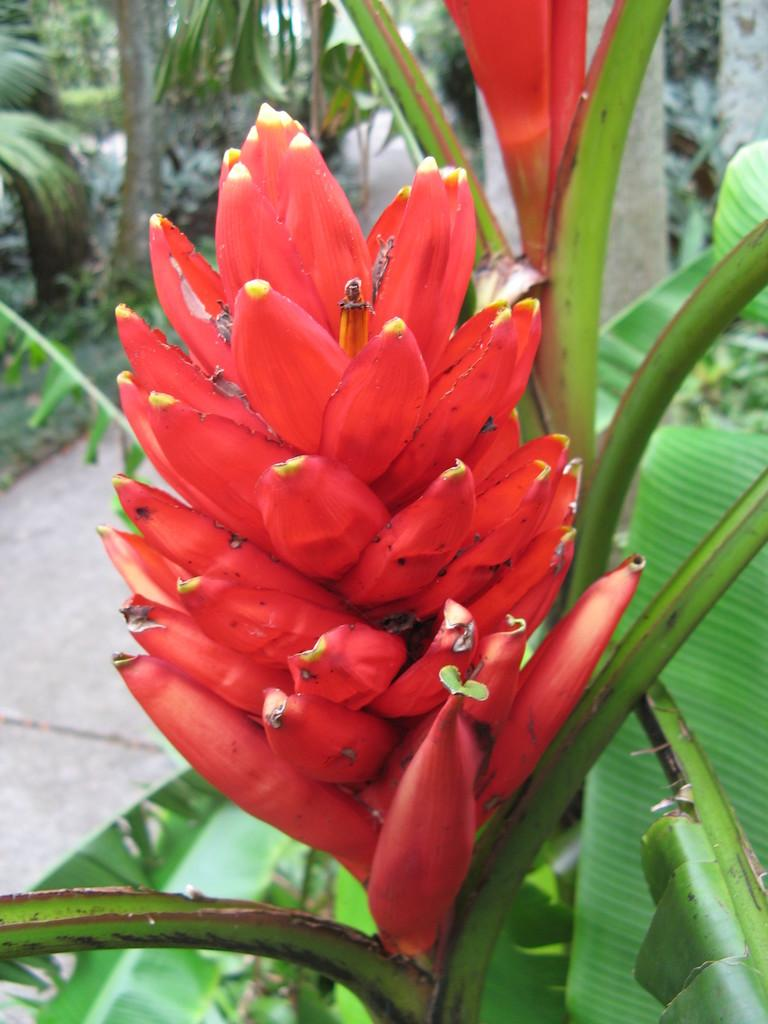What type of flower is in the image? There is a red flower in the image. What else can be seen in the image besides the flower? There are leaves and branches in the image. What type of account is being discussed in the image? There is no account being discussed in the image; it features a red flower, leaves, and branches. 